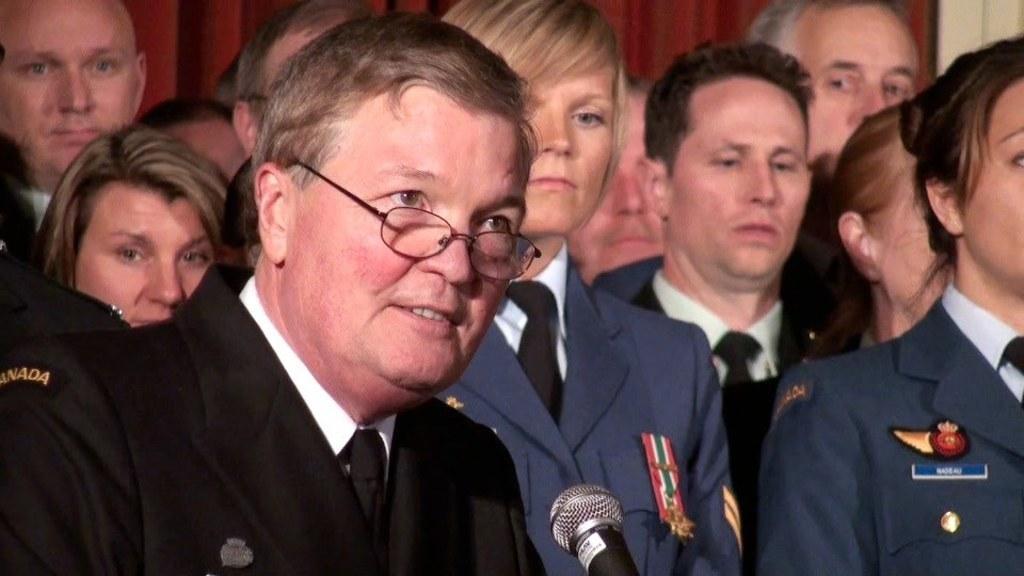Could you give a brief overview of what you see in this image? In this image we can see a few people, behind them there is a wall, in front of them, there is a mic. 